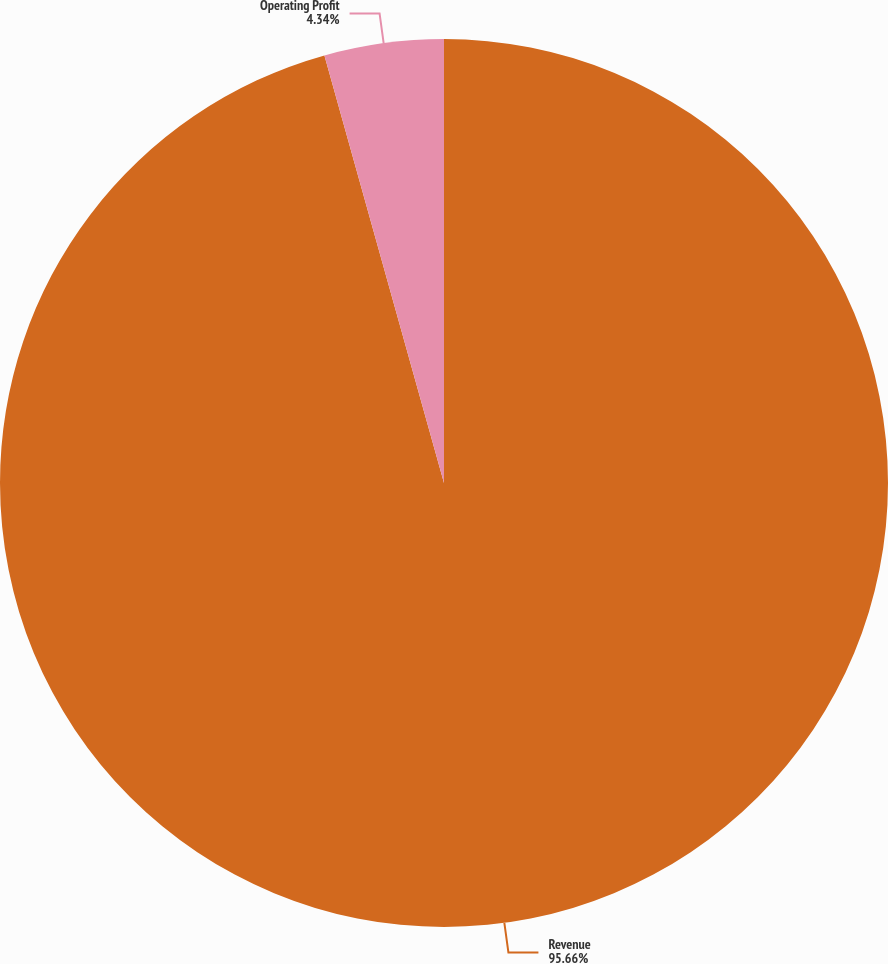Convert chart. <chart><loc_0><loc_0><loc_500><loc_500><pie_chart><fcel>Revenue<fcel>Operating Profit<nl><fcel>95.66%<fcel>4.34%<nl></chart> 